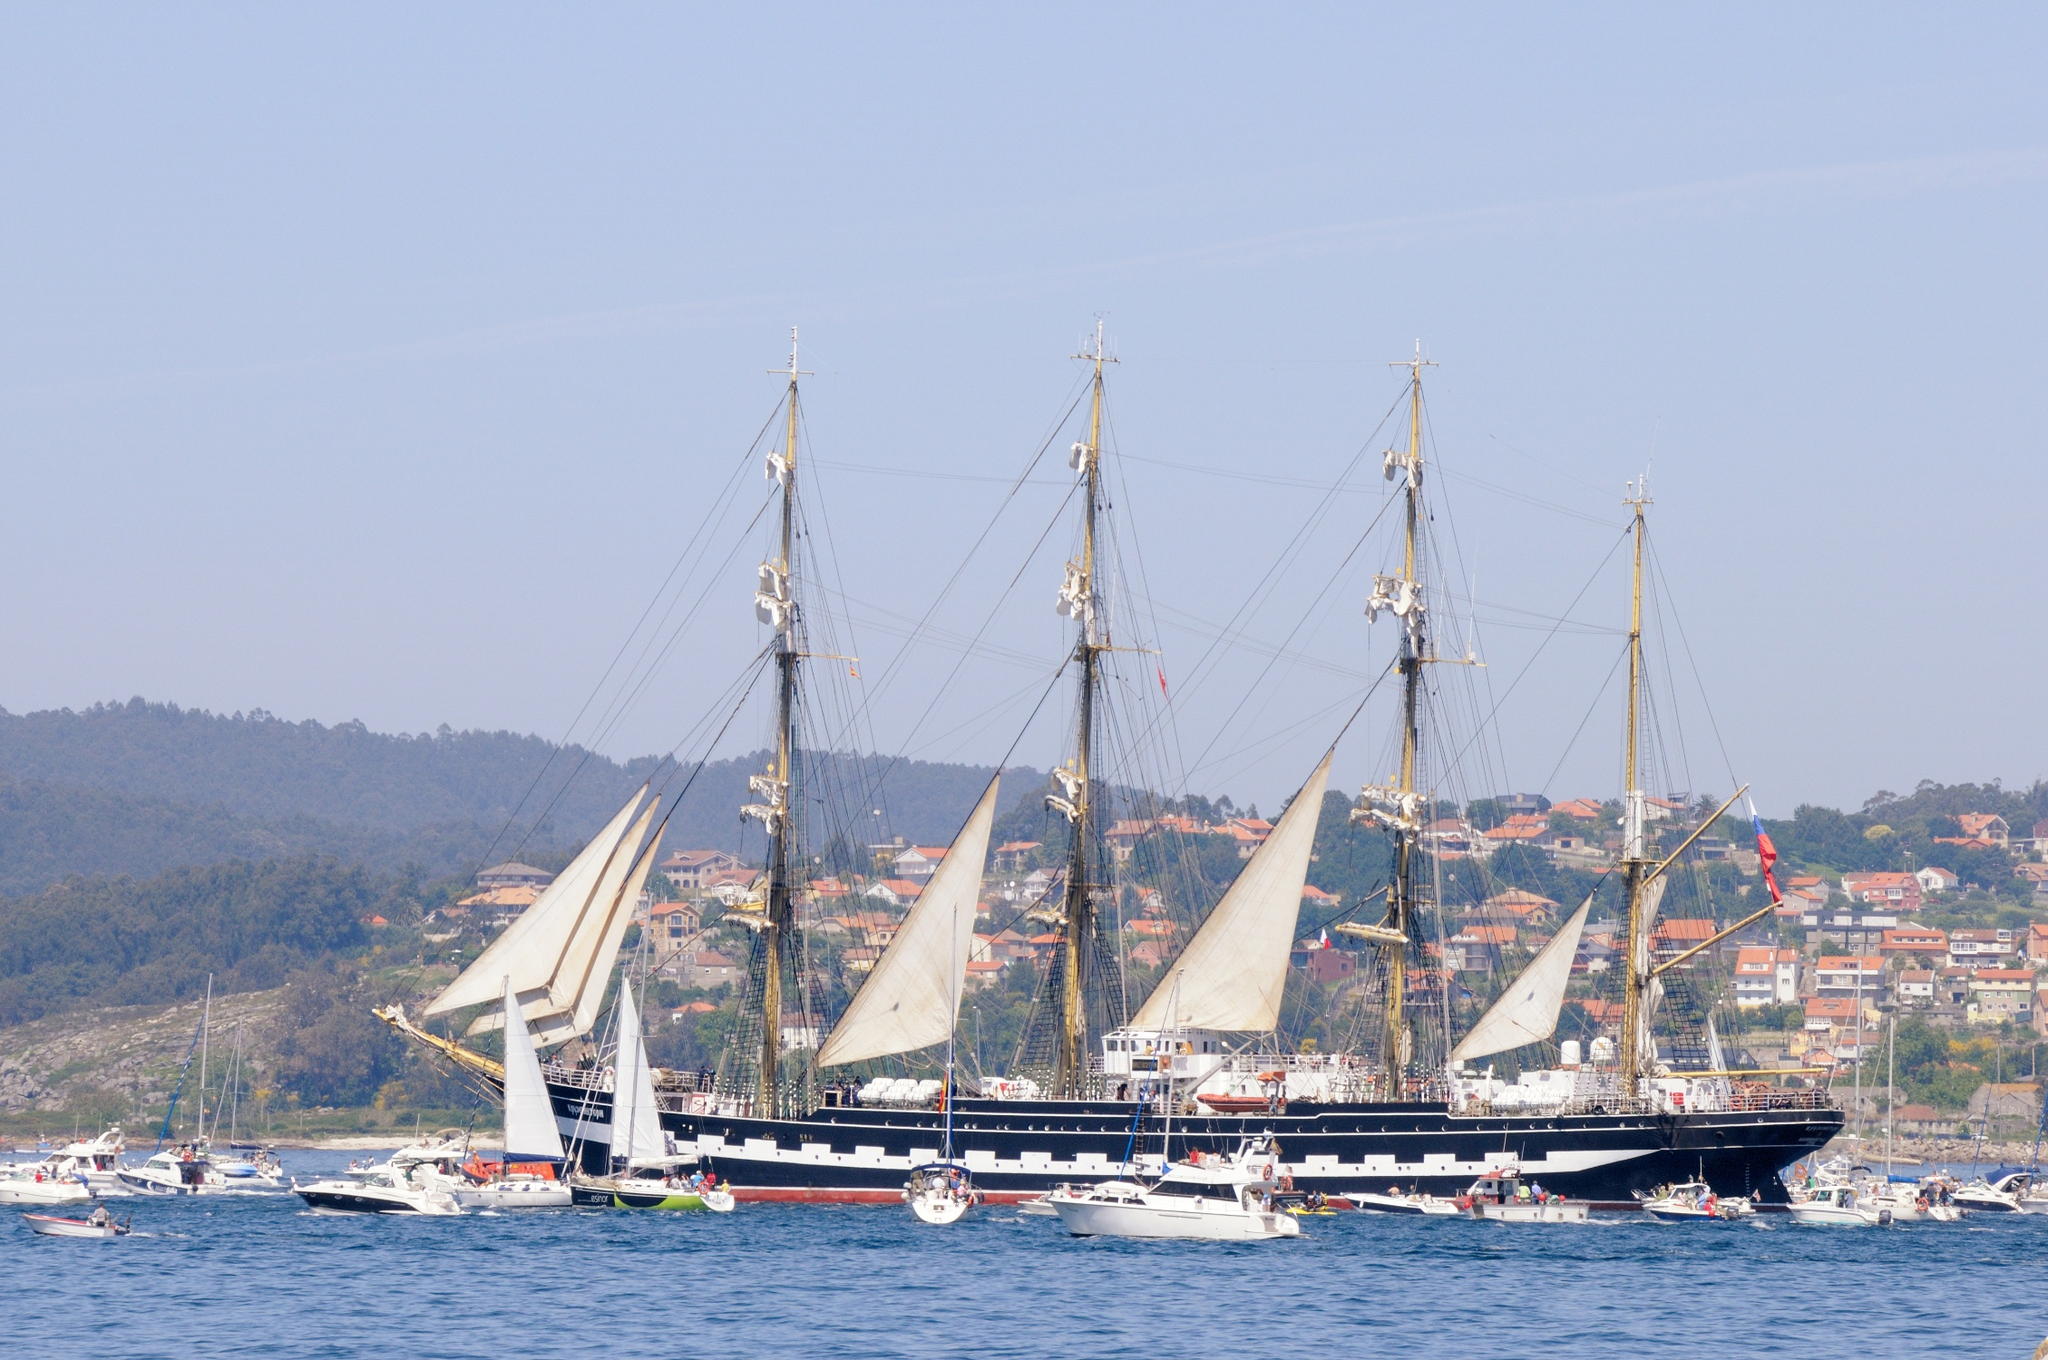Explain the visual content of the image in great detail. The image presents a stunning tall ship, which appears to be a barque with four tall masts, its hull painted in a deep navy blue tone. Several sails are partially unfurled, indicating that the ship may be in the process of setting sail or berthing. Surrounding the grand vessel is a flotilla of smaller boats, from sailboats to motorboats, bustling with activity. 

The scene takes place in a calm bay, with the gentle ripples of the water reflecting the clear sky overhead, contributing to the scene's picturesque quality. In the distance, a hillside is adorned with an array of buildings suggestive of a coastal town, nestled amidst verdant foliage. The composition is taken from a perspective on the water facing the shore, providing an expansive view of the ship and the charming environs that envelop it. 